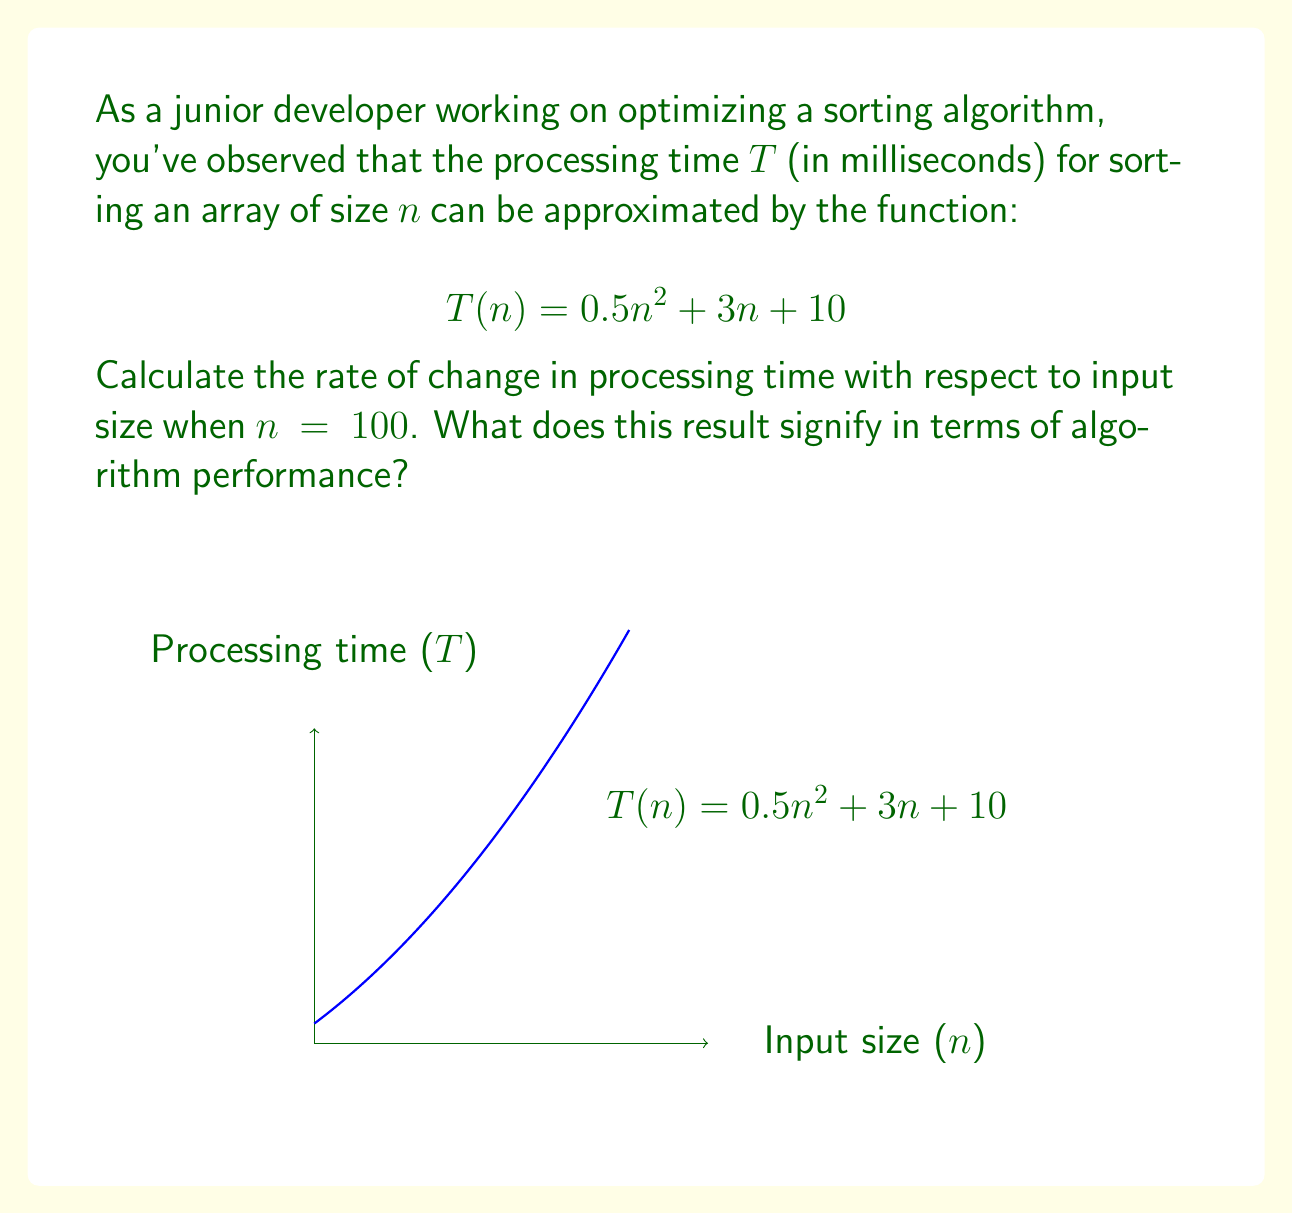Provide a solution to this math problem. To solve this problem, we need to follow these steps:

1) The rate of change of processing time with respect to input size is given by the derivative of $T(n)$ with respect to $n$.

2) Let's find $\frac{dT}{dn}$:
   $$\frac{dT}{dn} = \frac{d}{dn}(0.5n^2 + 3n + 10)$$
   $$= 0.5 \cdot 2n + 3 + 0$$
   $$= n + 3$$

3) Now, we need to evaluate this at $n = 100$:
   $$\frac{dT}{dn}\bigg|_{n=100} = 100 + 3 = 103$$

4) Interpretation: The rate of change at $n = 100$ is 103 ms per unit increase in input size. This means that when the input size is 100, for each additional element added to the input, the processing time increases by approximately 103 ms.

5) In terms of algorithm performance, this indicates that the processing time is increasing rapidly with input size. The quadratic term in the original function ($0.5n^2$) dominates as $n$ grows, suggesting that this algorithm has $O(n^2)$ time complexity, which is not ideal for large inputs.
Answer: 103 ms/unit; indicates quadratic time complexity 